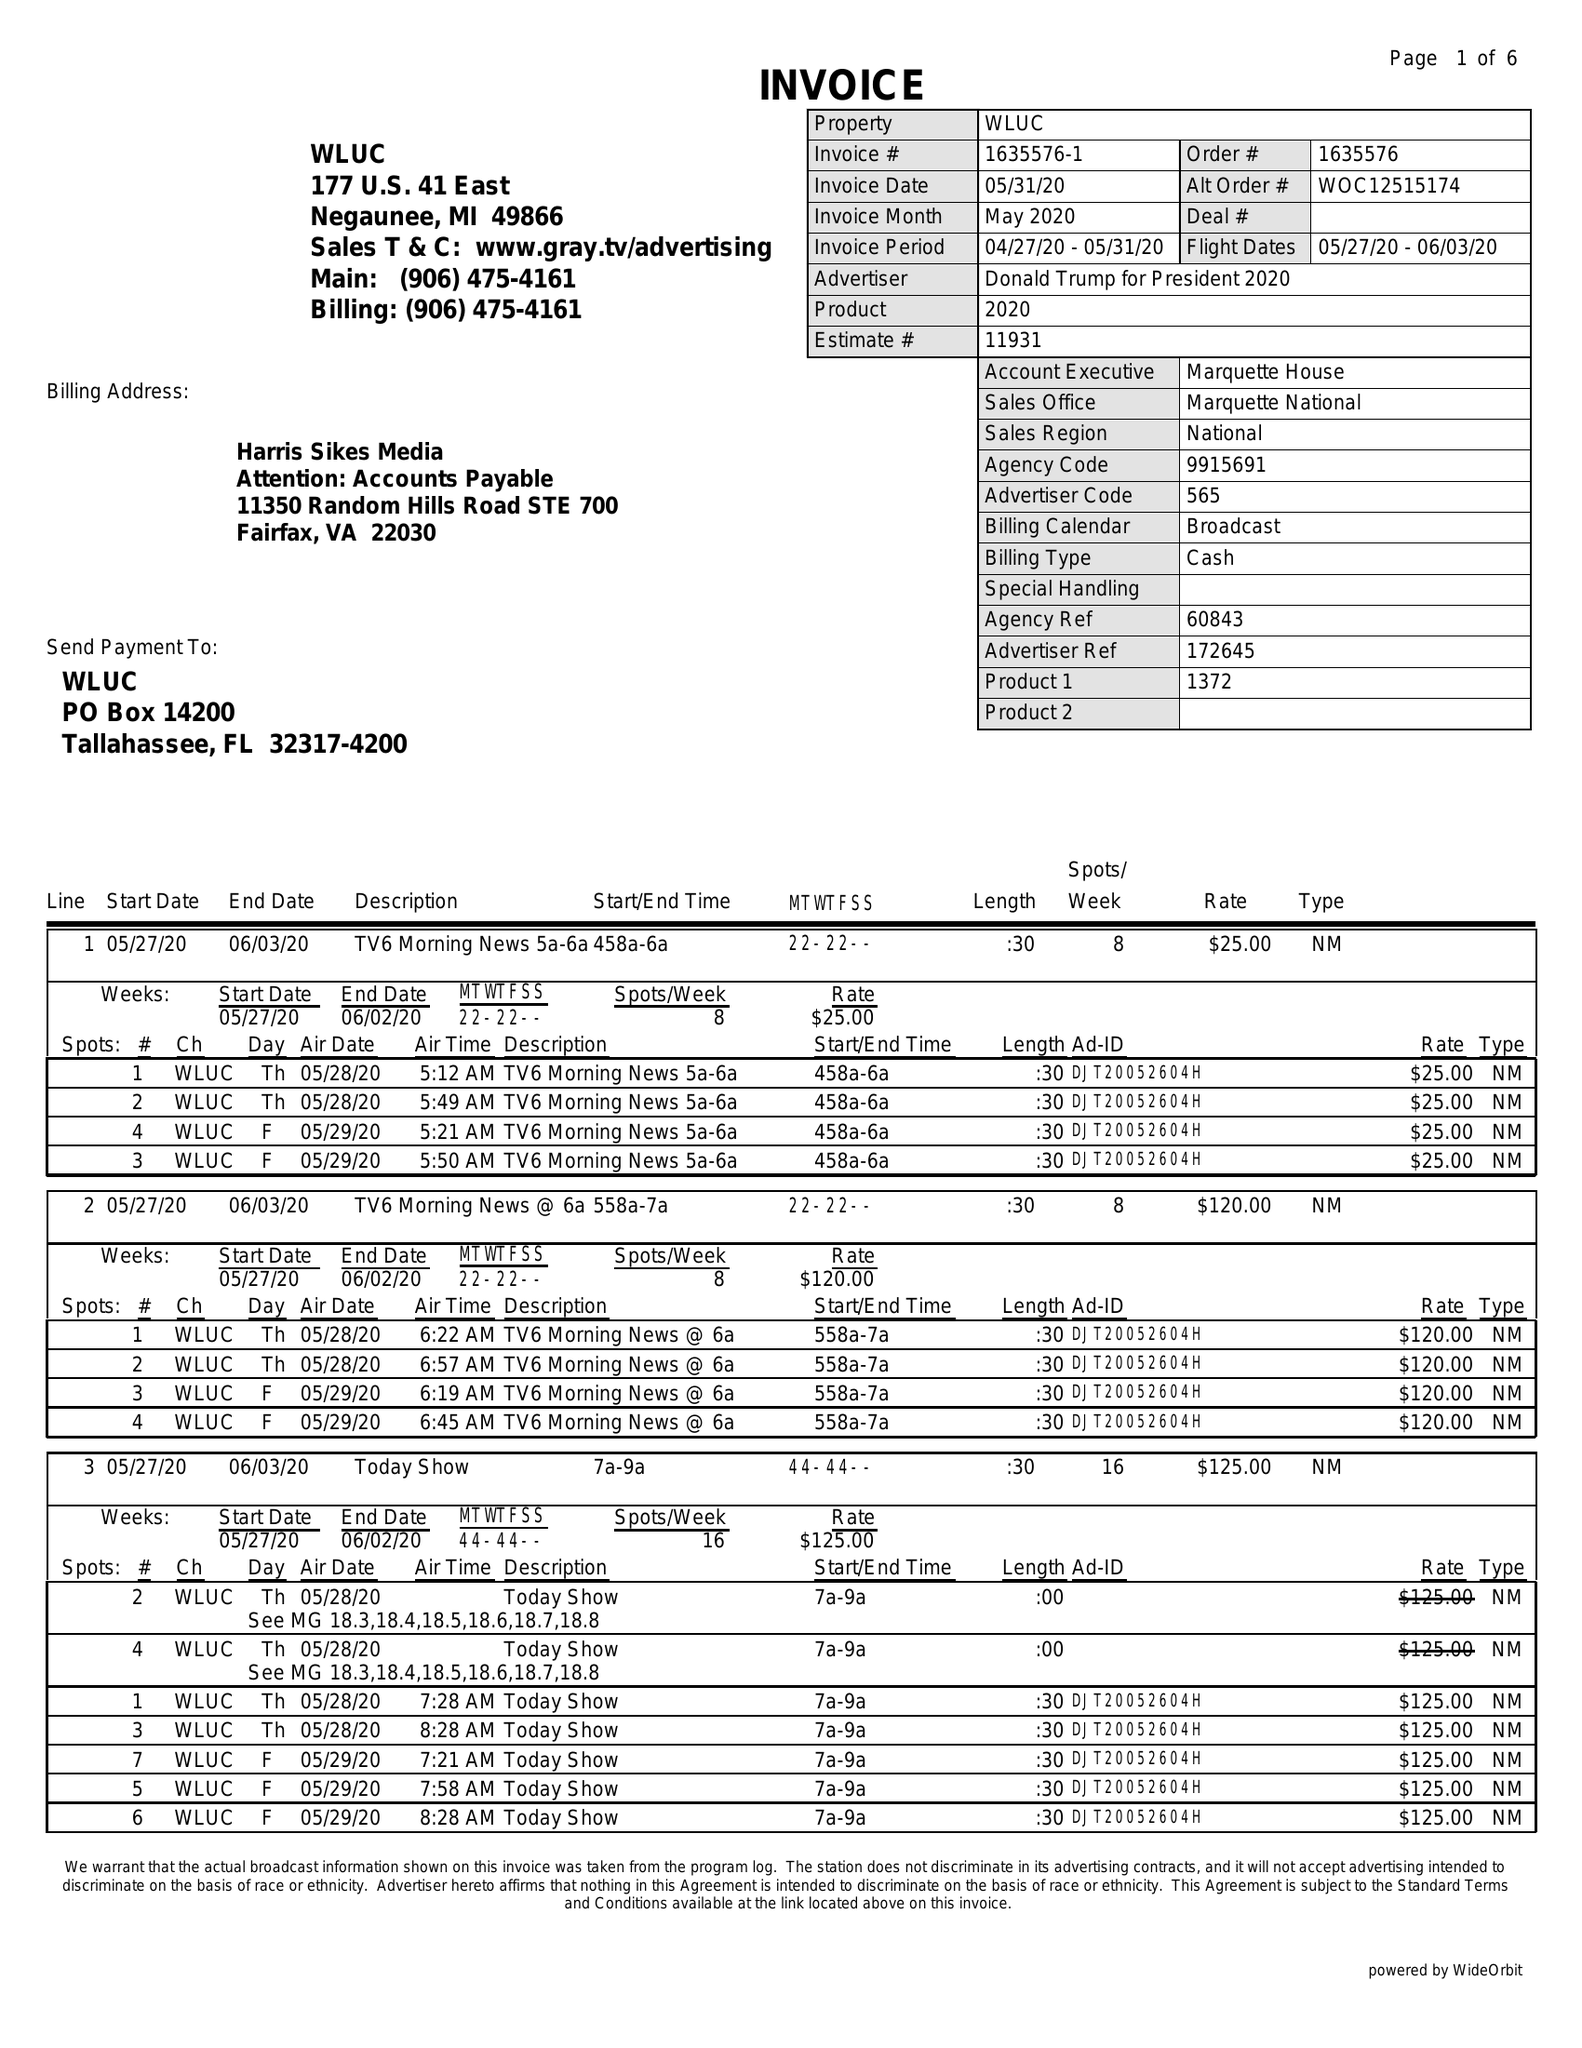What is the value for the flight_to?
Answer the question using a single word or phrase. 06/03/20 